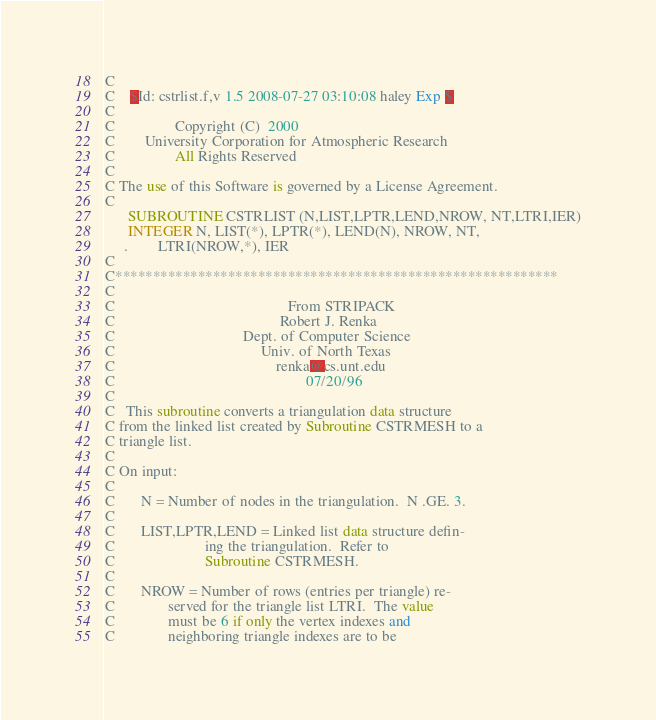<code> <loc_0><loc_0><loc_500><loc_500><_FORTRAN_>C
C	$Id: cstrlist.f,v 1.5 2008-07-27 03:10:08 haley Exp $
C                                                                      
C                Copyright (C)  2000
C        University Corporation for Atmospheric Research
C                All Rights Reserved
C
C The use of this Software is governed by a License Agreement.
C
      SUBROUTINE CSTRLIST (N,LIST,LPTR,LEND,NROW, NT,LTRI,IER)
      INTEGER N, LIST(*), LPTR(*), LEND(N), NROW, NT,
     .        LTRI(NROW,*), IER
C
C***********************************************************
C
C                                              From STRIPACK
C                                            Robert J. Renka
C                                  Dept. of Computer Science
C                                       Univ. of North Texas
C                                           renka@cs.unt.edu
C                                                   07/20/96
C
C   This subroutine converts a triangulation data structure
C from the linked list created by Subroutine CSTRMESH to a
C triangle list.
C
C On input:
C
C       N = Number of nodes in the triangulation.  N .GE. 3.
C
C       LIST,LPTR,LEND = Linked list data structure defin-
C                        ing the triangulation.  Refer to
C                        Subroutine CSTRMESH.
C
C       NROW = Number of rows (entries per triangle) re-
C              served for the triangle list LTRI.  The value
C              must be 6 if only the vertex indexes and
C              neighboring triangle indexes are to be</code> 